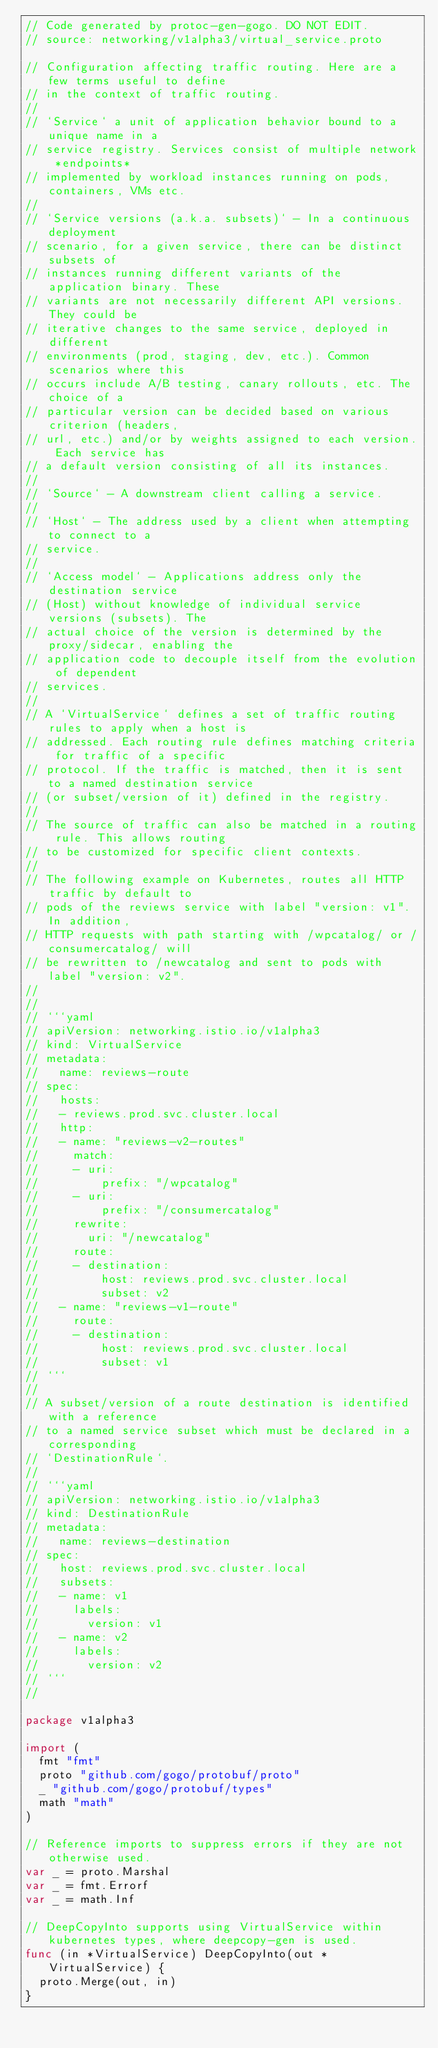Convert code to text. <code><loc_0><loc_0><loc_500><loc_500><_Go_>// Code generated by protoc-gen-gogo. DO NOT EDIT.
// source: networking/v1alpha3/virtual_service.proto

// Configuration affecting traffic routing. Here are a few terms useful to define
// in the context of traffic routing.
//
// `Service` a unit of application behavior bound to a unique name in a
// service registry. Services consist of multiple network *endpoints*
// implemented by workload instances running on pods, containers, VMs etc.
//
// `Service versions (a.k.a. subsets)` - In a continuous deployment
// scenario, for a given service, there can be distinct subsets of
// instances running different variants of the application binary. These
// variants are not necessarily different API versions. They could be
// iterative changes to the same service, deployed in different
// environments (prod, staging, dev, etc.). Common scenarios where this
// occurs include A/B testing, canary rollouts, etc. The choice of a
// particular version can be decided based on various criterion (headers,
// url, etc.) and/or by weights assigned to each version. Each service has
// a default version consisting of all its instances.
//
// `Source` - A downstream client calling a service.
//
// `Host` - The address used by a client when attempting to connect to a
// service.
//
// `Access model` - Applications address only the destination service
// (Host) without knowledge of individual service versions (subsets). The
// actual choice of the version is determined by the proxy/sidecar, enabling the
// application code to decouple itself from the evolution of dependent
// services.
//
// A `VirtualService` defines a set of traffic routing rules to apply when a host is
// addressed. Each routing rule defines matching criteria for traffic of a specific
// protocol. If the traffic is matched, then it is sent to a named destination service
// (or subset/version of it) defined in the registry.
//
// The source of traffic can also be matched in a routing rule. This allows routing
// to be customized for specific client contexts.
//
// The following example on Kubernetes, routes all HTTP traffic by default to
// pods of the reviews service with label "version: v1". In addition,
// HTTP requests with path starting with /wpcatalog/ or /consumercatalog/ will
// be rewritten to /newcatalog and sent to pods with label "version: v2".
//
//
// ```yaml
// apiVersion: networking.istio.io/v1alpha3
// kind: VirtualService
// metadata:
//   name: reviews-route
// spec:
//   hosts:
//   - reviews.prod.svc.cluster.local
//   http:
//   - name: "reviews-v2-routes"
//     match:
//     - uri:
//         prefix: "/wpcatalog"
//     - uri:
//         prefix: "/consumercatalog"
//     rewrite:
//       uri: "/newcatalog"
//     route:
//     - destination:
//         host: reviews.prod.svc.cluster.local
//         subset: v2
//   - name: "reviews-v1-route"
//     route:
//     - destination:
//         host: reviews.prod.svc.cluster.local
//         subset: v1
// ```
//
// A subset/version of a route destination is identified with a reference
// to a named service subset which must be declared in a corresponding
// `DestinationRule`.
//
// ```yaml
// apiVersion: networking.istio.io/v1alpha3
// kind: DestinationRule
// metadata:
//   name: reviews-destination
// spec:
//   host: reviews.prod.svc.cluster.local
//   subsets:
//   - name: v1
//     labels:
//       version: v1
//   - name: v2
//     labels:
//       version: v2
// ```
//

package v1alpha3

import (
	fmt "fmt"
	proto "github.com/gogo/protobuf/proto"
	_ "github.com/gogo/protobuf/types"
	math "math"
)

// Reference imports to suppress errors if they are not otherwise used.
var _ = proto.Marshal
var _ = fmt.Errorf
var _ = math.Inf

// DeepCopyInto supports using VirtualService within kubernetes types, where deepcopy-gen is used.
func (in *VirtualService) DeepCopyInto(out *VirtualService) {
	proto.Merge(out, in)
}
</code> 